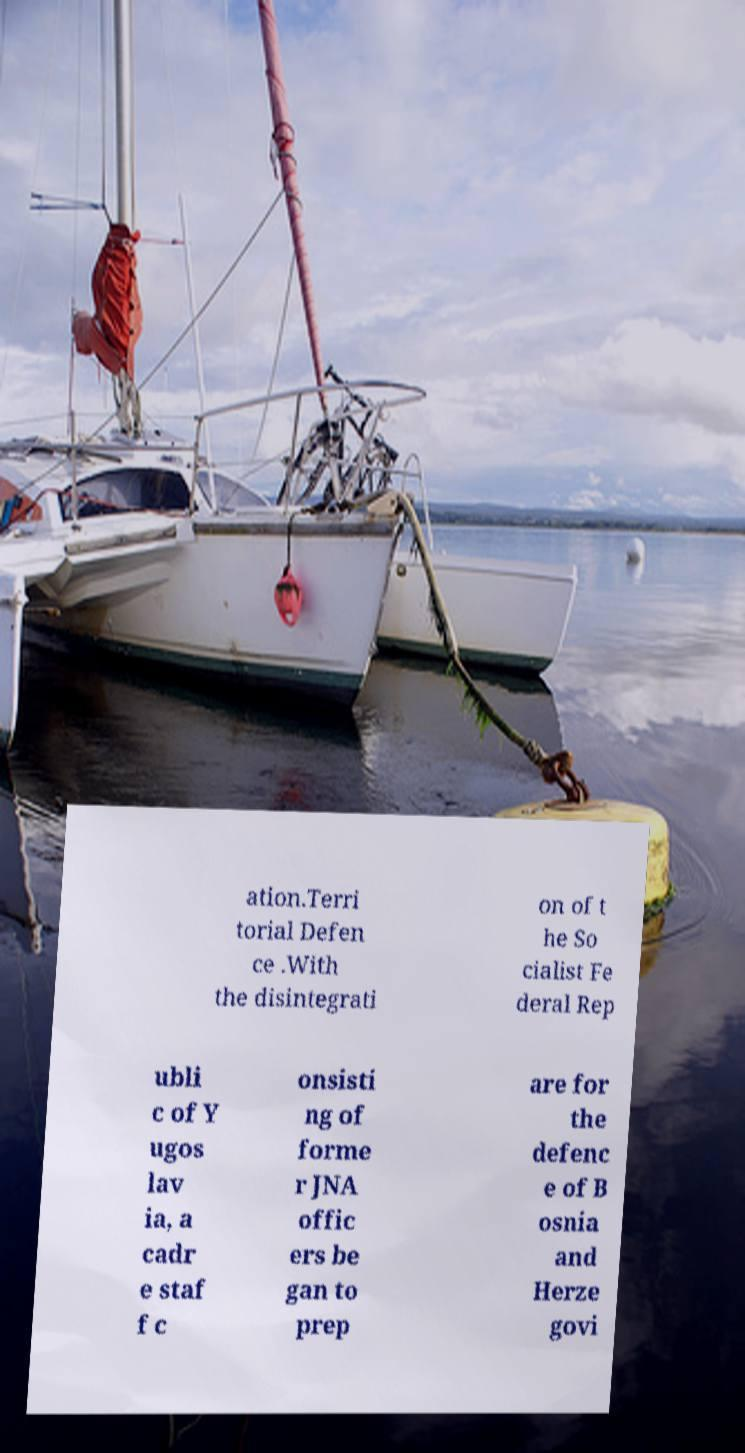Could you assist in decoding the text presented in this image and type it out clearly? ation.Terri torial Defen ce .With the disintegrati on of t he So cialist Fe deral Rep ubli c of Y ugos lav ia, a cadr e staf f c onsisti ng of forme r JNA offic ers be gan to prep are for the defenc e of B osnia and Herze govi 